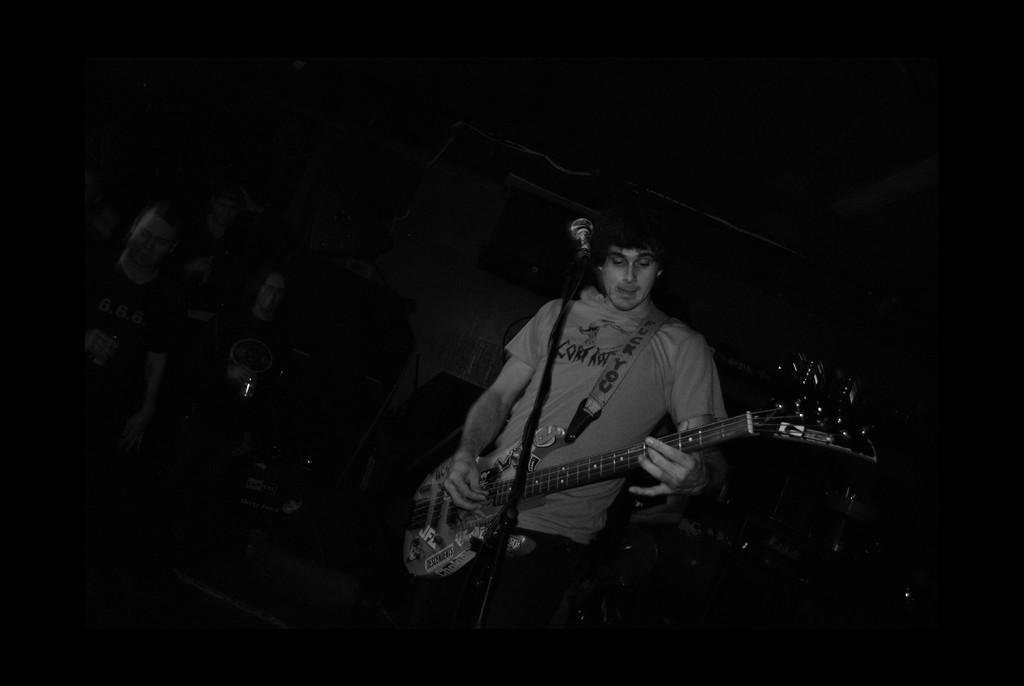Could you give a brief overview of what you see in this image? In this image I see a man who is holding a guitar and is standing in front of a mic. 